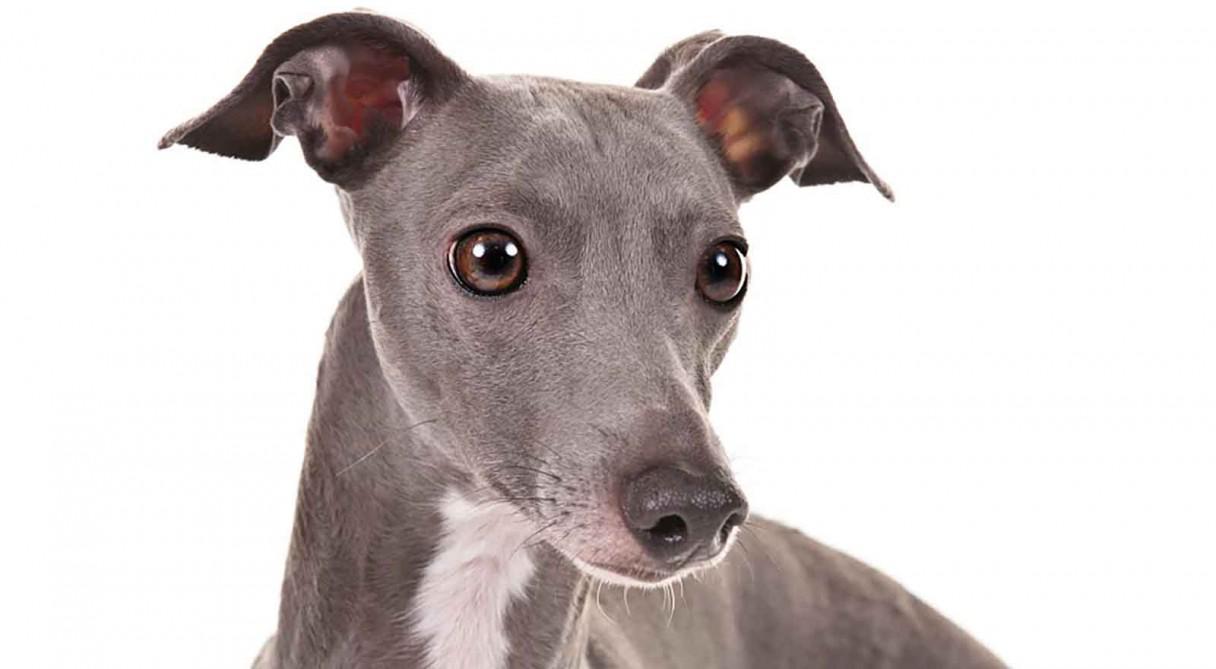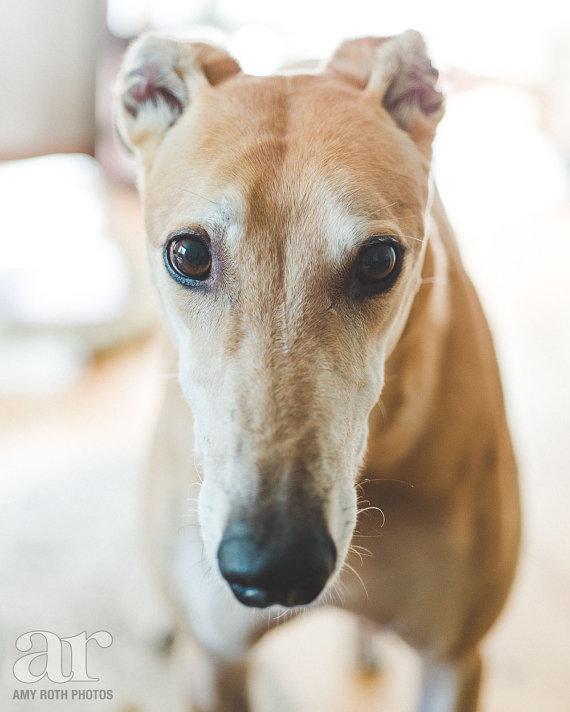The first image is the image on the left, the second image is the image on the right. Analyze the images presented: Is the assertion "One of the dogs has a collar." valid? Answer yes or no. No. 